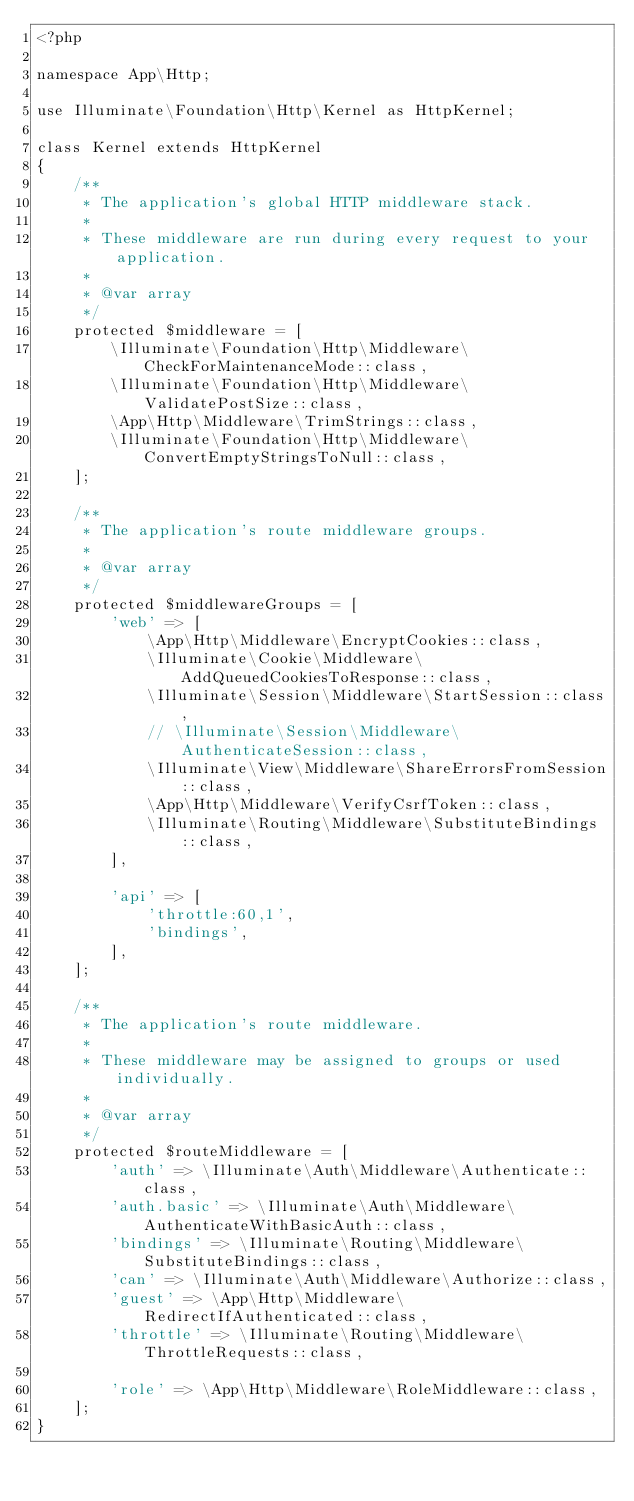<code> <loc_0><loc_0><loc_500><loc_500><_PHP_><?php

namespace App\Http;

use Illuminate\Foundation\Http\Kernel as HttpKernel;

class Kernel extends HttpKernel
{
    /**
     * The application's global HTTP middleware stack.
     *
     * These middleware are run during every request to your application.
     *
     * @var array
     */
    protected $middleware = [
        \Illuminate\Foundation\Http\Middleware\CheckForMaintenanceMode::class,
        \Illuminate\Foundation\Http\Middleware\ValidatePostSize::class,
        \App\Http\Middleware\TrimStrings::class,
        \Illuminate\Foundation\Http\Middleware\ConvertEmptyStringsToNull::class,
    ];

    /**
     * The application's route middleware groups.
     *
     * @var array
     */
    protected $middlewareGroups = [
        'web' => [
            \App\Http\Middleware\EncryptCookies::class,
            \Illuminate\Cookie\Middleware\AddQueuedCookiesToResponse::class,
            \Illuminate\Session\Middleware\StartSession::class,
            // \Illuminate\Session\Middleware\AuthenticateSession::class,
            \Illuminate\View\Middleware\ShareErrorsFromSession::class,
            \App\Http\Middleware\VerifyCsrfToken::class,
            \Illuminate\Routing\Middleware\SubstituteBindings::class,
        ],

        'api' => [
            'throttle:60,1',
            'bindings',
        ],
    ];

    /**
     * The application's route middleware.
     *
     * These middleware may be assigned to groups or used individually.
     *
     * @var array
     */
    protected $routeMiddleware = [
        'auth' => \Illuminate\Auth\Middleware\Authenticate::class,
        'auth.basic' => \Illuminate\Auth\Middleware\AuthenticateWithBasicAuth::class,
        'bindings' => \Illuminate\Routing\Middleware\SubstituteBindings::class,
        'can' => \Illuminate\Auth\Middleware\Authorize::class,
        'guest' => \App\Http\Middleware\RedirectIfAuthenticated::class,
        'throttle' => \Illuminate\Routing\Middleware\ThrottleRequests::class,

        'role' => \App\Http\Middleware\RoleMiddleware::class,
    ];
}
</code> 